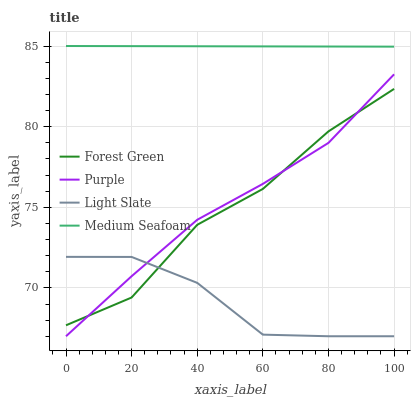Does Light Slate have the minimum area under the curve?
Answer yes or no. Yes. Does Medium Seafoam have the maximum area under the curve?
Answer yes or no. Yes. Does Forest Green have the minimum area under the curve?
Answer yes or no. No. Does Forest Green have the maximum area under the curve?
Answer yes or no. No. Is Medium Seafoam the smoothest?
Answer yes or no. Yes. Is Forest Green the roughest?
Answer yes or no. Yes. Is Light Slate the smoothest?
Answer yes or no. No. Is Light Slate the roughest?
Answer yes or no. No. Does Purple have the lowest value?
Answer yes or no. Yes. Does Forest Green have the lowest value?
Answer yes or no. No. Does Medium Seafoam have the highest value?
Answer yes or no. Yes. Does Forest Green have the highest value?
Answer yes or no. No. Is Forest Green less than Medium Seafoam?
Answer yes or no. Yes. Is Medium Seafoam greater than Forest Green?
Answer yes or no. Yes. Does Light Slate intersect Purple?
Answer yes or no. Yes. Is Light Slate less than Purple?
Answer yes or no. No. Is Light Slate greater than Purple?
Answer yes or no. No. Does Forest Green intersect Medium Seafoam?
Answer yes or no. No. 